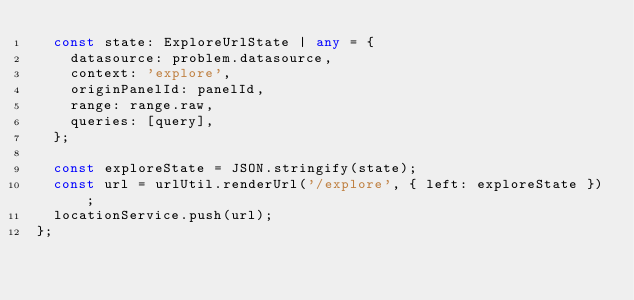<code> <loc_0><loc_0><loc_500><loc_500><_TypeScript_>  const state: ExploreUrlState | any = {
    datasource: problem.datasource,
    context: 'explore',
    originPanelId: panelId,
    range: range.raw,
    queries: [query],
  };

  const exploreState = JSON.stringify(state);
  const url = urlUtil.renderUrl('/explore', { left: exploreState });
  locationService.push(url);
};

</code> 